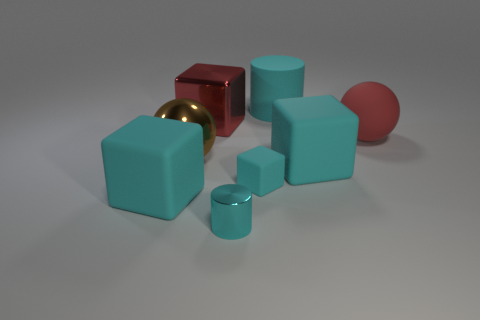How many large red metallic objects are the same shape as the brown metal object?
Your answer should be very brief. 0. There is a object that is the same color as the shiny cube; what is it made of?
Keep it short and to the point. Rubber. Does the small cube have the same material as the large red block?
Your response must be concise. No. There is a large red thing that is to the left of the big sphere to the right of the tiny cyan metal cylinder; how many big cyan rubber cubes are to the left of it?
Give a very brief answer. 1. Are there any large cyan cylinders made of the same material as the red block?
Keep it short and to the point. No. What is the size of the matte cylinder that is the same color as the shiny cylinder?
Your response must be concise. Large. Is the number of cyan rubber objects less than the number of large brown metallic spheres?
Make the answer very short. No. Do the matte thing that is on the left side of the small cyan cylinder and the small matte cube have the same color?
Provide a succinct answer. Yes. The small thing that is behind the cylinder in front of the large cyan matte cube left of the big red cube is made of what material?
Provide a short and direct response. Rubber. Are there any things of the same color as the small cube?
Ensure brevity in your answer.  Yes. 